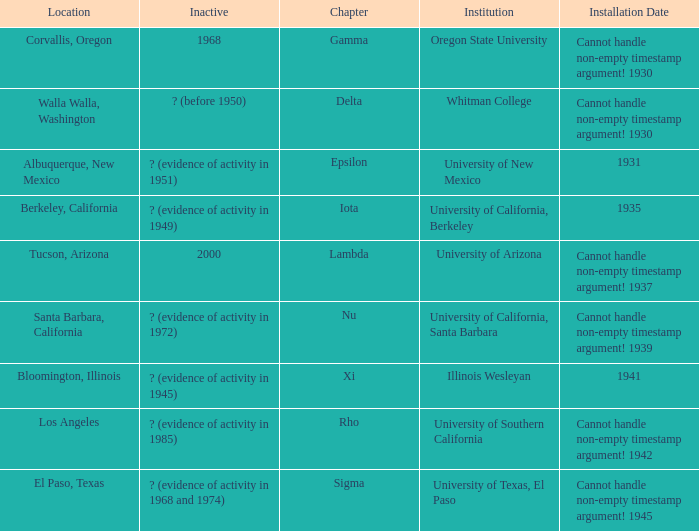What is the installation date for the Delta Chapter? Cannot handle non-empty timestamp argument! 1930. Could you help me parse every detail presented in this table? {'header': ['Location', 'Inactive', 'Chapter', 'Institution', 'Installation Date'], 'rows': [['Corvallis, Oregon', '1968', 'Gamma', 'Oregon State University', 'Cannot handle non-empty timestamp argument! 1930'], ['Walla Walla, Washington', '? (before 1950)', 'Delta', 'Whitman College', 'Cannot handle non-empty timestamp argument! 1930'], ['Albuquerque, New Mexico', '? (evidence of activity in 1951)', 'Epsilon', 'University of New Mexico', '1931'], ['Berkeley, California', '? (evidence of activity in 1949)', 'Iota', 'University of California, Berkeley', '1935'], ['Tucson, Arizona', '2000', 'Lambda', 'University of Arizona', 'Cannot handle non-empty timestamp argument! 1937'], ['Santa Barbara, California', '? (evidence of activity in 1972)', 'Nu', 'University of California, Santa Barbara', 'Cannot handle non-empty timestamp argument! 1939'], ['Bloomington, Illinois', '? (evidence of activity in 1945)', 'Xi', 'Illinois Wesleyan', '1941'], ['Los Angeles', '? (evidence of activity in 1985)', 'Rho', 'University of Southern California', 'Cannot handle non-empty timestamp argument! 1942'], ['El Paso, Texas', '? (evidence of activity in 1968 and 1974)', 'Sigma', 'University of Texas, El Paso', 'Cannot handle non-empty timestamp argument! 1945']]} 